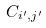<formula> <loc_0><loc_0><loc_500><loc_500>C _ { i ^ { \prime } , j ^ { \prime } }</formula> 